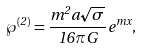<formula> <loc_0><loc_0><loc_500><loc_500>\wp ^ { ( 2 ) } = \frac { m ^ { 2 } a \sqrt { \sigma } } { 1 6 \pi G } \, e ^ { m x } ,</formula> 